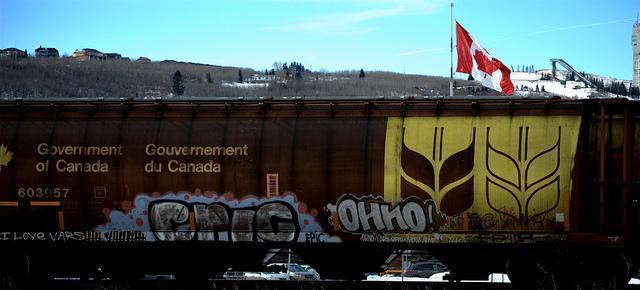How many people in the shot?
Give a very brief answer. 0. 